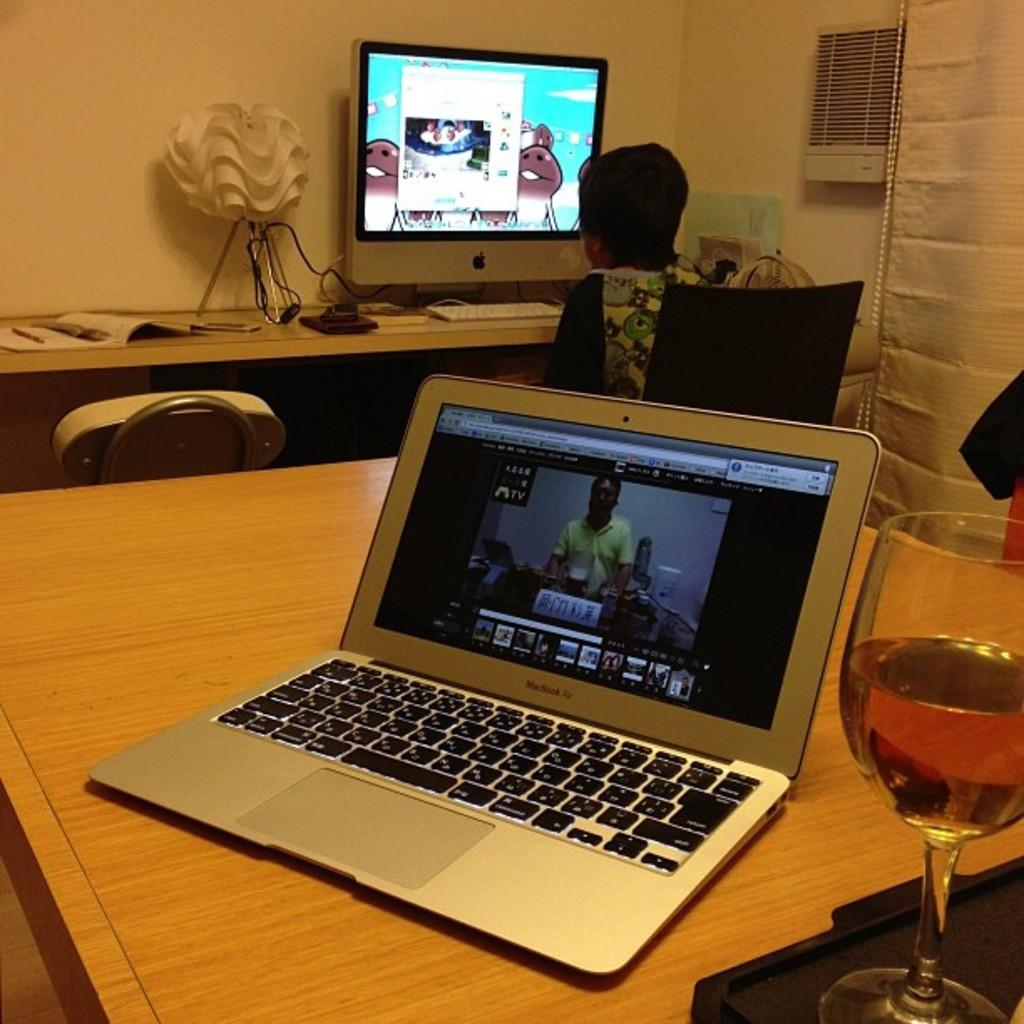What electronic device is visible in the image? There is a laptop in the image. What is placed next to the laptop on the table? There is a wine glass on the table next to the laptop. Where are the laptop and wine glass located in the image? Both the laptop and wine glass are on a table. Can you describe the person in the background of the image? There is a person sitting in a chair in the background of the image, and they are watching a screen. What other objects can be seen in the background of the image? There is a lamp and a chair in the background of the image. What sound does the ring make in the image? There is no ring present in the image, so it is not possible to determine the sound it might make. 